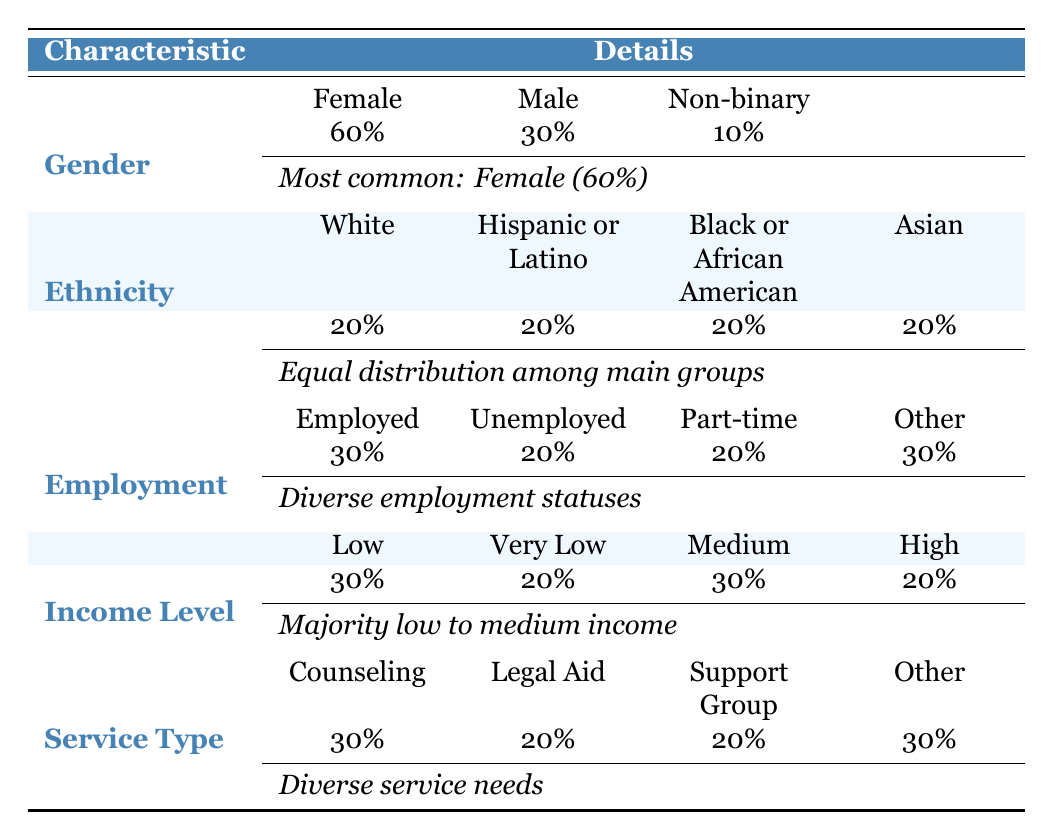What percentage of individuals seeking support services are Female? The table states that 60% of individuals are Female, as noted under the Gender section.
Answer: 60% What is the income level that has the highest representation among the individuals? Both the Low and Medium income levels have 30% each, which is higher than Very Low and High levels, which are 20% each.
Answer: Low and Medium Is the distribution of ethnicity among the individuals even? The table indicates that each ethnic group (White, Hispanic or Latino, Black or African American, and Asian) has equal representation at 20%, indicating an even distribution.
Answer: Yes What is the total percentage of individuals who are Unemployed or Part-time? The table shows Unemployed at 20% and Part-time at 20%, summing these gives 20% + 20% = 40%.
Answer: 40% How many support service types are represented in the table? There are four distinct support service types mentioned: Counseling, Legal Aid, Support Group, and Crisis Management.
Answer: Four What is the most common employment status reported by the individuals? The highest percentage for employment status is 30% for both Employed and Other categories, as they tie in the representation.
Answer: Employed and Other Which location is mentioned most frequently in this demographic data? The table does not specify a single location with the highest count as it only lists individuals without repeating locations.
Answer: No location is mentioned most frequently Are there more females or males among those seeking support services? The table indicates that there are 60% females and 30% males. Hence, females are more represented than males.
Answer: More females What percentage of individuals are seeking Counseling services? Counseling services represent 30%, as indicated in the Service Type section of the table.
Answer: 30% What is the percentage of individuals who are either Unemployed or have a High income level? Unemployed is 20% and High income level is 20%. Thus, combining these gives a total of 20% + 20% = 40%.
Answer: 40% 